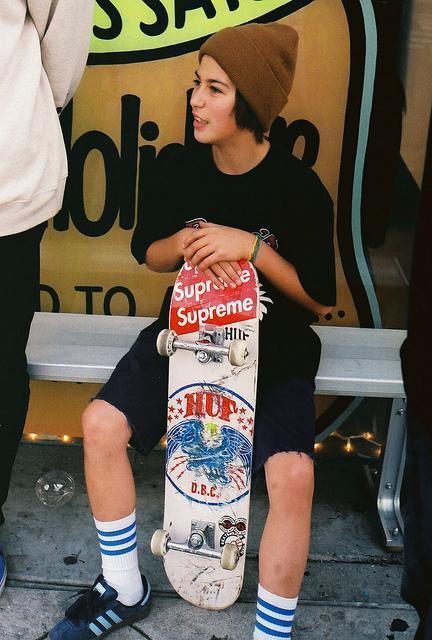How many people are there?
Give a very brief answer. 2. 